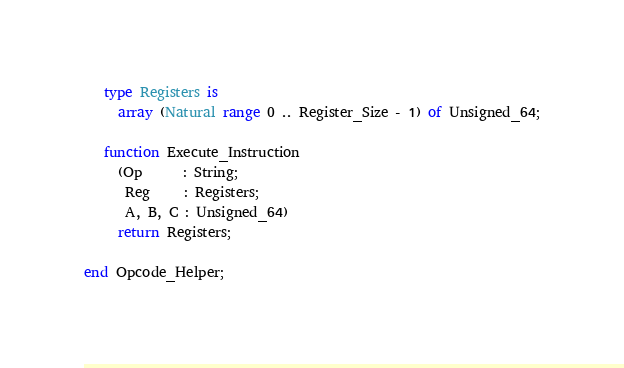<code> <loc_0><loc_0><loc_500><loc_500><_Ada_>   type Registers is
     array (Natural range 0 .. Register_Size - 1) of Unsigned_64;

   function Execute_Instruction
     (Op      : String;
      Reg     : Registers;
      A, B, C : Unsigned_64)
     return Registers;

end Opcode_Helper;
</code> 